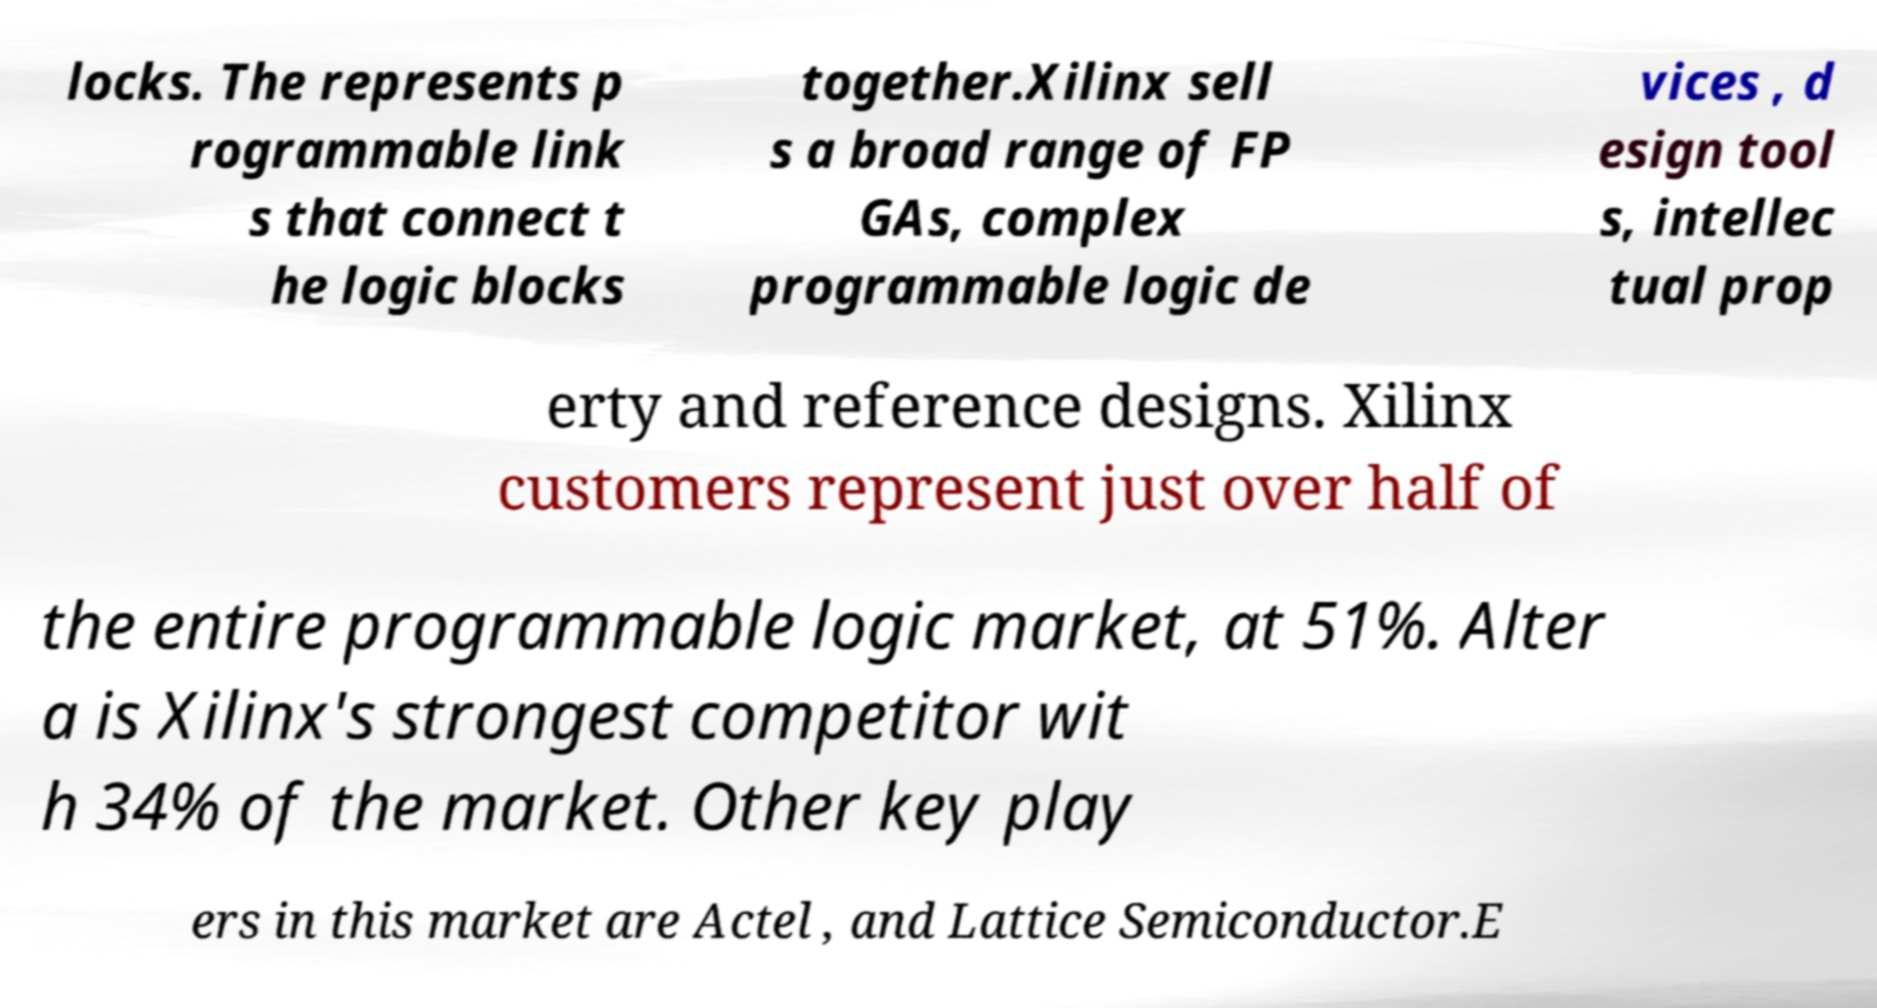Please read and relay the text visible in this image. What does it say? locks. The represents p rogrammable link s that connect t he logic blocks together.Xilinx sell s a broad range of FP GAs, complex programmable logic de vices , d esign tool s, intellec tual prop erty and reference designs. Xilinx customers represent just over half of the entire programmable logic market, at 51%. Alter a is Xilinx's strongest competitor wit h 34% of the market. Other key play ers in this market are Actel , and Lattice Semiconductor.E 